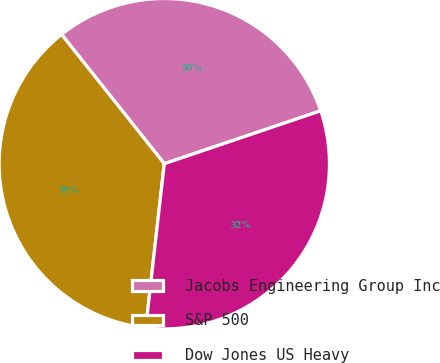Convert chart. <chart><loc_0><loc_0><loc_500><loc_500><pie_chart><fcel>Jacobs Engineering Group Inc<fcel>S&P 500<fcel>Dow Jones US Heavy<nl><fcel>30.49%<fcel>37.52%<fcel>31.98%<nl></chart> 